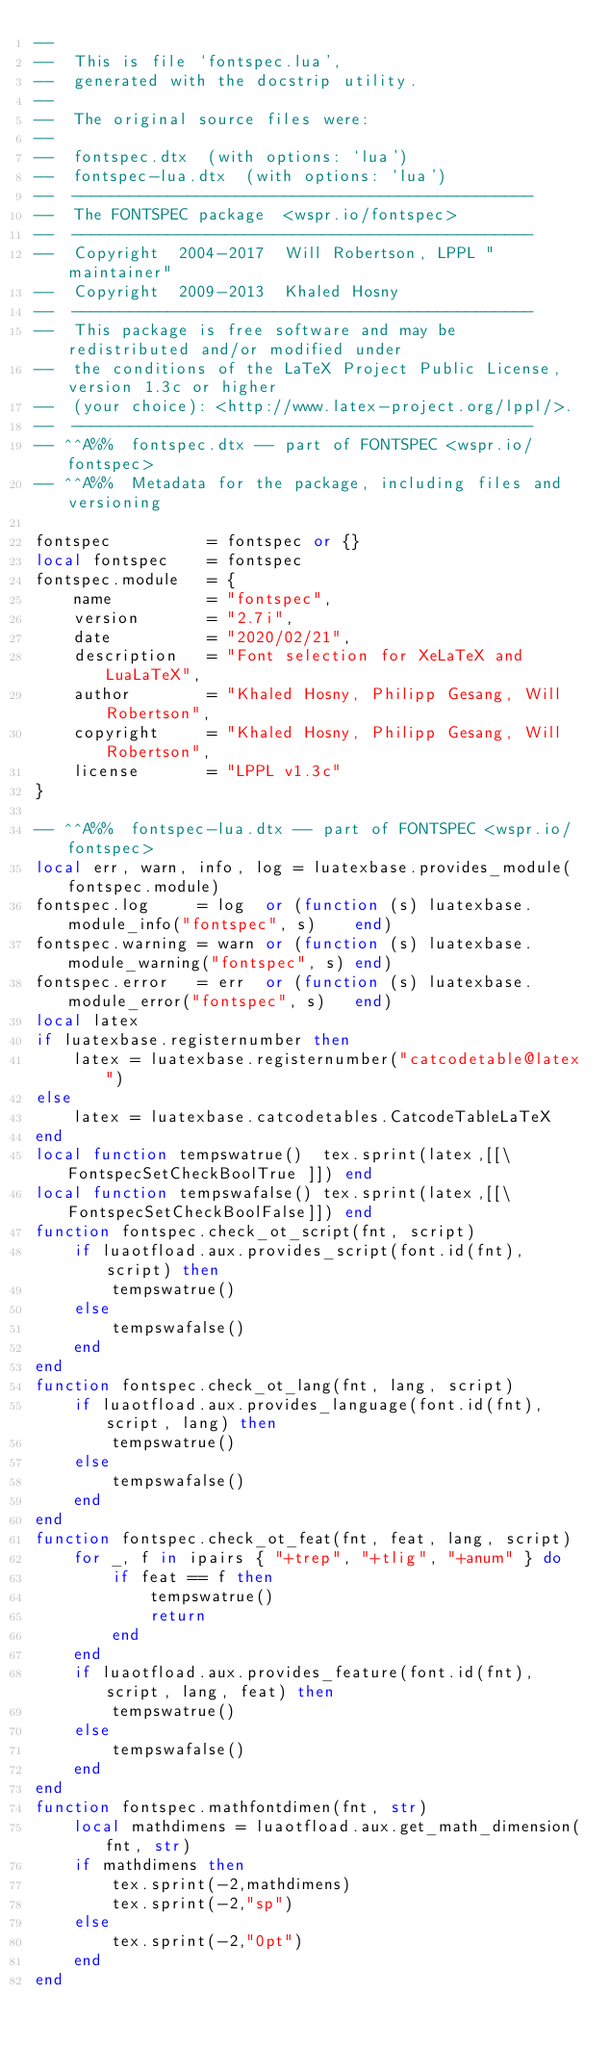<code> <loc_0><loc_0><loc_500><loc_500><_Lua_>-- 
--  This is file `fontspec.lua',
--  generated with the docstrip utility.
-- 
--  The original source files were:
-- 
--  fontspec.dtx  (with options: `lua')
--  fontspec-lua.dtx  (with options: `lua')
--  ------------------------------------------------
--  The FONTSPEC package  <wspr.io/fontspec>
--  ------------------------------------------------
--  Copyright  2004-2017  Will Robertson, LPPL "maintainer"
--  Copyright  2009-2013  Khaled Hosny
--  ------------------------------------------------
--  This package is free software and may be redistributed and/or modified under
--  the conditions of the LaTeX Project Public License, version 1.3c or higher
--  (your choice): <http://www.latex-project.org/lppl/>.
--  ------------------------------------------------
-- ^^A%%  fontspec.dtx -- part of FONTSPEC <wspr.io/fontspec>
-- ^^A%%  Metadata for the package, including files and versioning

fontspec          = fontspec or {}
local fontspec    = fontspec
fontspec.module   = {
    name          = "fontspec",
    version       = "2.7i",
    date          = "2020/02/21",
    description   = "Font selection for XeLaTeX and LuaLaTeX",
    author        = "Khaled Hosny, Philipp Gesang, Will Robertson",
    copyright     = "Khaled Hosny, Philipp Gesang, Will Robertson",
    license       = "LPPL v1.3c"
}

-- ^^A%%  fontspec-lua.dtx -- part of FONTSPEC <wspr.io/fontspec>
local err, warn, info, log = luatexbase.provides_module(fontspec.module)
fontspec.log     = log  or (function (s) luatexbase.module_info("fontspec", s)    end)
fontspec.warning = warn or (function (s) luatexbase.module_warning("fontspec", s) end)
fontspec.error   = err  or (function (s) luatexbase.module_error("fontspec", s)   end)
local latex
if luatexbase.registernumber then
    latex = luatexbase.registernumber("catcodetable@latex")
else
    latex = luatexbase.catcodetables.CatcodeTableLaTeX
end
local function tempswatrue()  tex.sprint(latex,[[\FontspecSetCheckBoolTrue ]]) end
local function tempswafalse() tex.sprint(latex,[[\FontspecSetCheckBoolFalse]]) end
function fontspec.check_ot_script(fnt, script)
    if luaotfload.aux.provides_script(font.id(fnt), script) then
        tempswatrue()
    else
        tempswafalse()
    end
end
function fontspec.check_ot_lang(fnt, lang, script)
    if luaotfload.aux.provides_language(font.id(fnt), script, lang) then
        tempswatrue()
    else
        tempswafalse()
    end
end
function fontspec.check_ot_feat(fnt, feat, lang, script)
    for _, f in ipairs { "+trep", "+tlig", "+anum" } do
        if feat == f then
            tempswatrue()
            return
        end
    end
    if luaotfload.aux.provides_feature(font.id(fnt), script, lang, feat) then
        tempswatrue()
    else
        tempswafalse()
    end
end
function fontspec.mathfontdimen(fnt, str)
    local mathdimens = luaotfload.aux.get_math_dimension(fnt, str)
    if mathdimens then
        tex.sprint(-2,mathdimens)
        tex.sprint(-2,"sp")
    else
        tex.sprint(-2,"0pt")
    end
end

</code> 